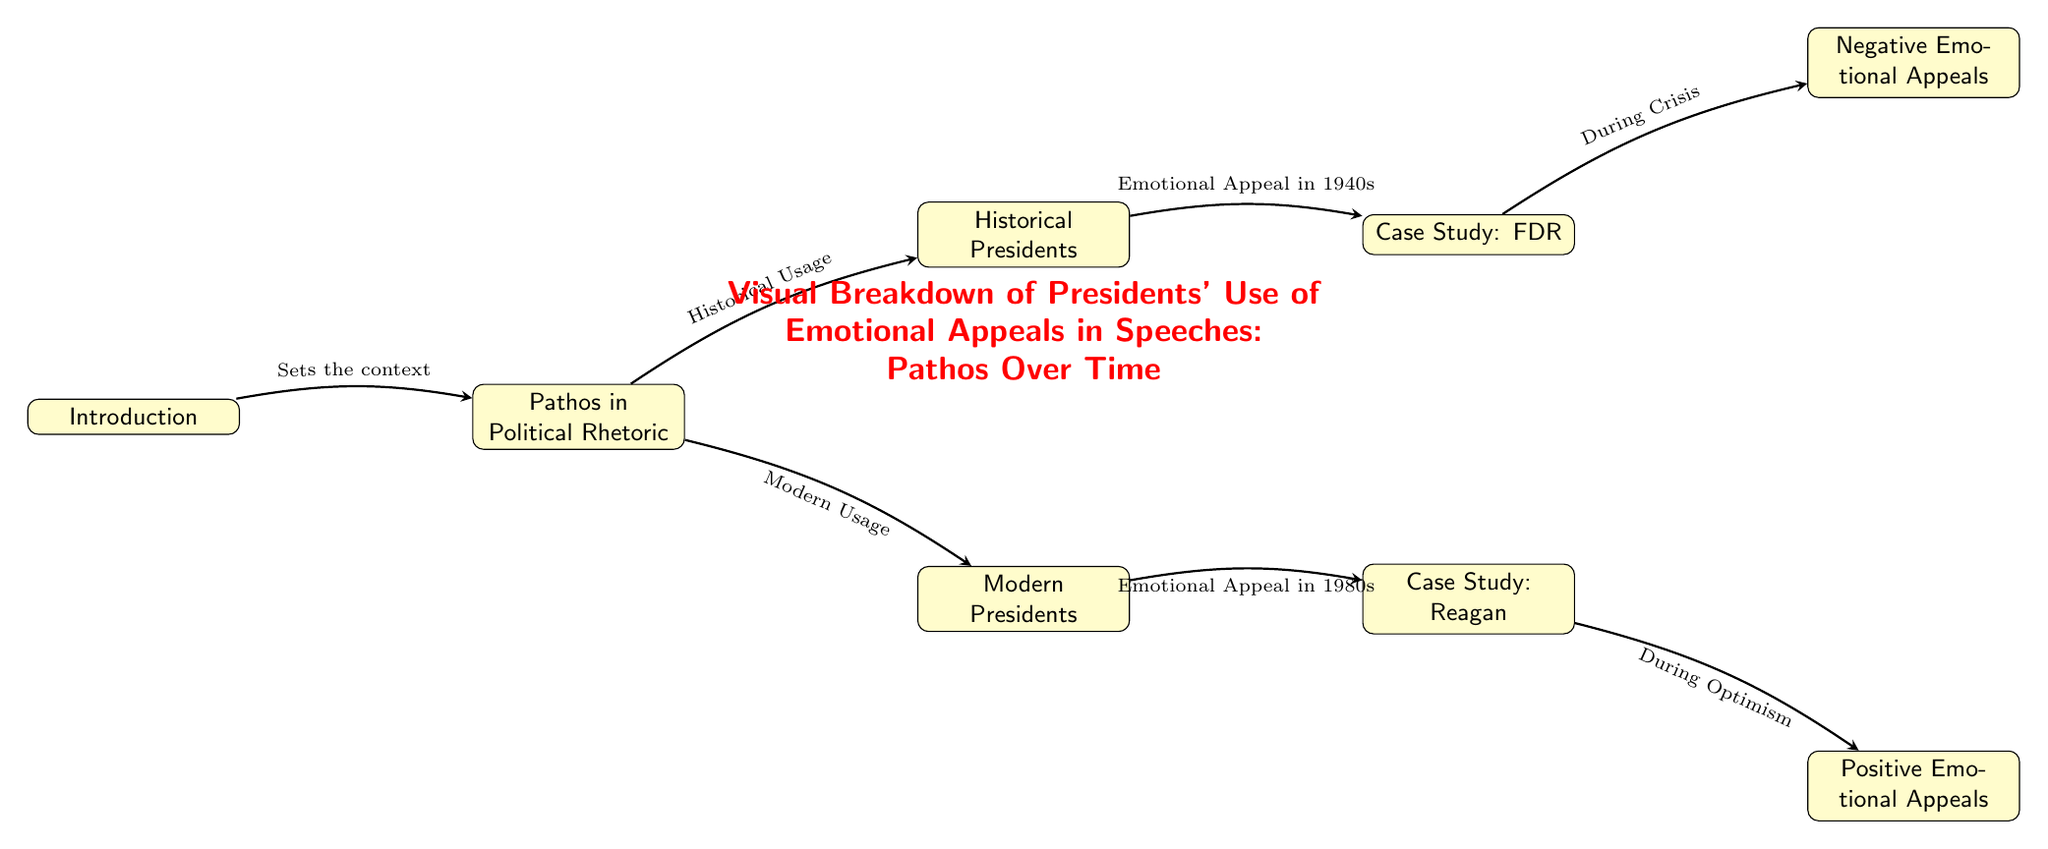What are the two main categories discussed under Pathos? The diagram shows two main categories under Pathos: Historical Presidents and Modern Presidents, indicated as nodes below the Pathos in Political Rhetoric node.
Answer: Historical Presidents, Modern Presidents Which president is linked with the emotional appeal in the 1940s? The diagram connects the case study of FDR with the emotional appeal in the 1940s, as FDR is positioned directly to the right of the Historical Presidents node.
Answer: FDR How many case studies are represented in the diagram? The diagram features two case studies: one for FDR and one for Reagan, as seen in the nodes connected under the respective Historical and Modern Presidents.
Answer: 2 What type of emotional appeal is associated with the 1980s? The diagram indicates that the case study for Reagan is connected to positive emotional appeals, as represented in the node directly below Reagan's case study.
Answer: Positive Emotional Appeals What does the arrow from the Introduction to Pathos indicate? The arrow signifies that the Introduction sets the context for the discussion on Pathos in Political Rhetoric, as shown with a label on the connecting line.
Answer: Sets the context Which type of emotional appeals does FDR primarily use according to the diagram? The diagram specifies that FDR is associated with negative emotional appeals, established by the connection between FDR and the Negative Emotional Appeals node.
Answer: Negative Emotional Appeals What is the overall title of the diagram's content? The title of the diagram, which summarizes its focus, is directly stated at the top and is explicitly marked in red as the visual header.
Answer: Visual Breakdown of Presidents' Use of Emotional Appeals in Speeches: Pathos Over Time How is Modern Usage characterized in the diagram? Modern Usage is associated with the emotional appeal in the 1980s, which corresponds to the case study of Reagan, as shown in the edges connecting to the Modern Presidents node.
Answer: Emotional Appeal in 1980s 